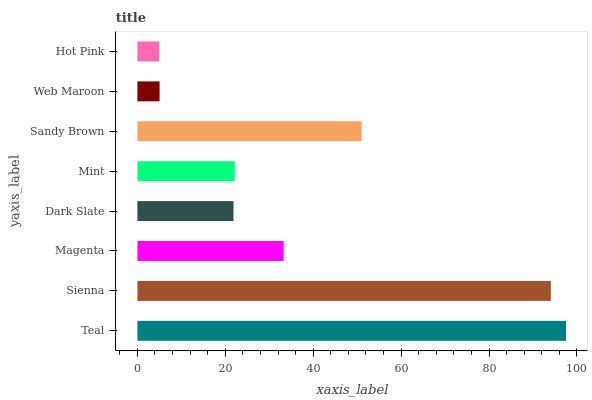Is Hot Pink the minimum?
Answer yes or no. Yes. Is Teal the maximum?
Answer yes or no. Yes. Is Sienna the minimum?
Answer yes or no. No. Is Sienna the maximum?
Answer yes or no. No. Is Teal greater than Sienna?
Answer yes or no. Yes. Is Sienna less than Teal?
Answer yes or no. Yes. Is Sienna greater than Teal?
Answer yes or no. No. Is Teal less than Sienna?
Answer yes or no. No. Is Magenta the high median?
Answer yes or no. Yes. Is Mint the low median?
Answer yes or no. Yes. Is Teal the high median?
Answer yes or no. No. Is Magenta the low median?
Answer yes or no. No. 